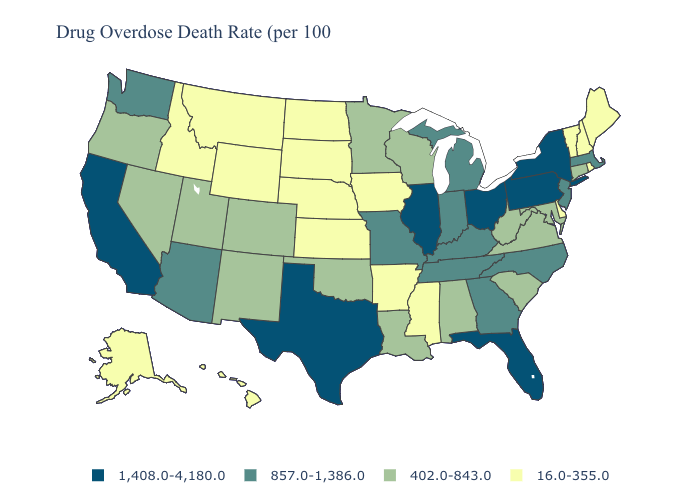What is the value of Minnesota?
Give a very brief answer. 402.0-843.0. Name the states that have a value in the range 1,408.0-4,180.0?
Keep it brief. California, Florida, Illinois, New York, Ohio, Pennsylvania, Texas. Does Vermont have the lowest value in the USA?
Be succinct. Yes. What is the value of North Dakota?
Be succinct. 16.0-355.0. Which states have the lowest value in the South?
Short answer required. Arkansas, Delaware, Mississippi. Does New York have the lowest value in the Northeast?
Answer briefly. No. Name the states that have a value in the range 1,408.0-4,180.0?
Short answer required. California, Florida, Illinois, New York, Ohio, Pennsylvania, Texas. Which states have the lowest value in the West?
Concise answer only. Alaska, Hawaii, Idaho, Montana, Wyoming. Does Illinois have the highest value in the USA?
Short answer required. Yes. Name the states that have a value in the range 402.0-843.0?
Write a very short answer. Alabama, Colorado, Connecticut, Louisiana, Maryland, Minnesota, Nevada, New Mexico, Oklahoma, Oregon, South Carolina, Utah, Virginia, West Virginia, Wisconsin. What is the value of Wisconsin?
Be succinct. 402.0-843.0. Among the states that border New Mexico , which have the highest value?
Write a very short answer. Texas. Which states have the highest value in the USA?
Concise answer only. California, Florida, Illinois, New York, Ohio, Pennsylvania, Texas. Name the states that have a value in the range 857.0-1,386.0?
Quick response, please. Arizona, Georgia, Indiana, Kentucky, Massachusetts, Michigan, Missouri, New Jersey, North Carolina, Tennessee, Washington. 